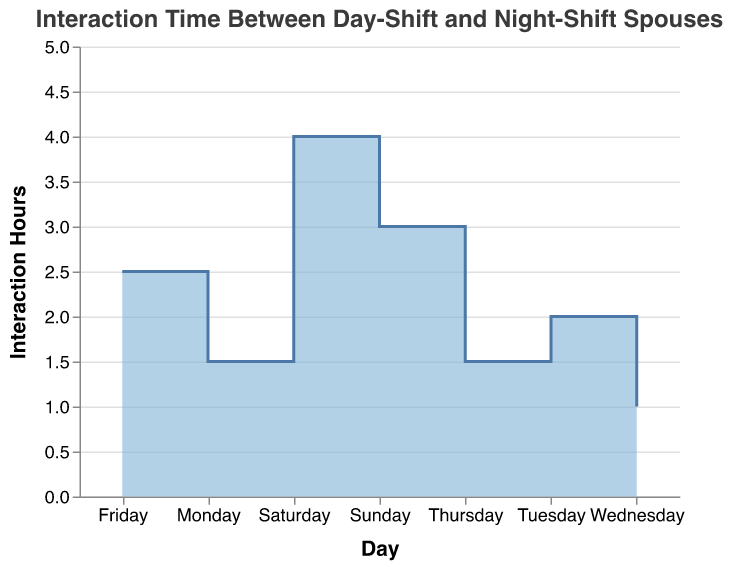What is the title of the chart? The title of the chart is often displayed at the top and provides a brief description of the chart's content. In this case, it reads "Interaction Time Between Day-Shift and Night-Shift Spouses."
Answer: Interaction Time Between Day-Shift and Night-Shift Spouses On which day do the spouses interact the most? The y-axis represents Interaction Hours, and you can see the highest data point on Saturday, reaching 4 hours.
Answer: Saturday What are the two days with the least interaction time? By looking at the y-axis values and comparing data points, it is noticeable that Monday, Thursday, and Wednesday have lower interaction times compared to other days, with Wednesday having the absolute lowest.
Answer: Wednesday and Monday/Thursday (1 hour each) What's the total interaction time over the week? Sum the interaction hours for each day: 1.5 (Mon) + 2 (Tue) + 1 (Wed) + 1.5 (Thu) + 2.5 (Fri) + 4 (Sat) + 3 (Sun) = 15.5 hours.
Answer: 15.5 hours Is there a day with the same interaction time as another day? By comparing the y-values, Monday (1.5 hours) and Thursday (1.5 hours) have the same interaction time.
Answer: Yes, Monday and Thursday Which day shows an increase in interaction time compared to the previous day? Tuesday shows an increase from Monday (1.5 to 2 hours), Thursday shows no increase compared to Wednesday (1 to 1.5), and Saturday shows a notable jump from Friday (2.5 to 4).
Answer: Tuesday, Saturday, and Sunday What is the average interaction time during weekdays (Monday to Friday)? Add interaction hours for weekdays and divide by 5: (1.5 + 2 + 1 + 1.5 + 2.5) / 5 = 8.5 / 5 = 1.7 hours.
Answer: 1.7 hours Between which consecutive days is the largest increase in interaction time? Check the differences; the largest is between Friday (2.5) and Saturday (4), a difference of 1.5 hours.
Answer: Friday to Saturday By how much does the interaction time vary from Wednesday to Friday? Subtract Wednesday's interaction time from Friday's: 2.5 - 1 = 1.5 hours.
Answer: 1.5 hours 